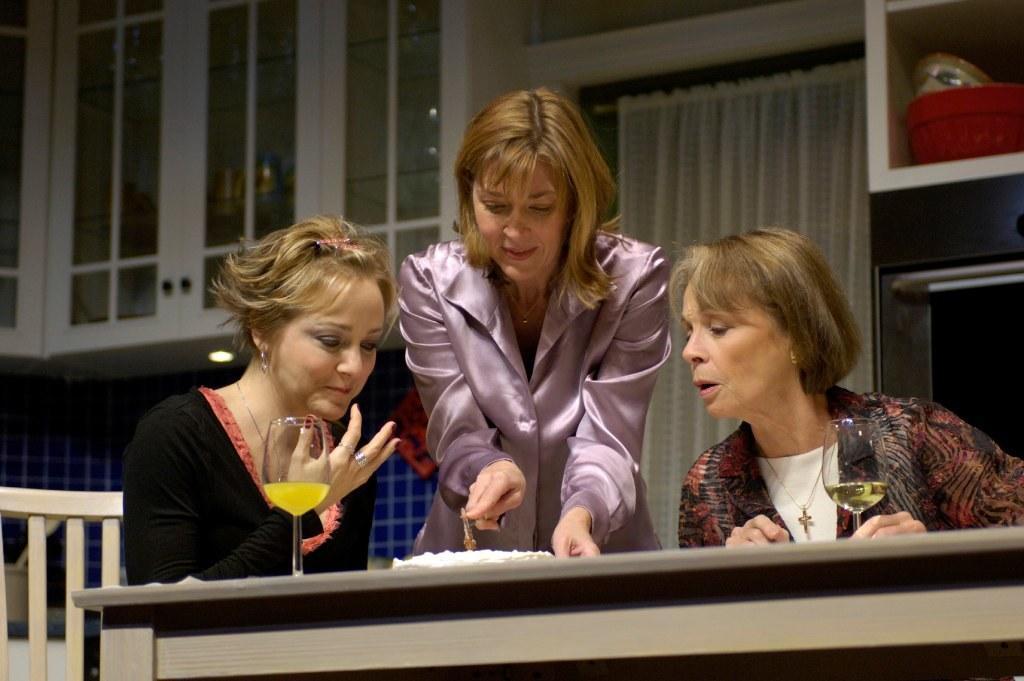Please provide a concise description of this image. On the background we can see cupboard, white curtain and a red basket in a cupboard. here we can see one women at the right side of the picture holding a glass in her hand. At the left side of the picture we can see other women sitting on a chair in front of a table and there is a glass and a cake on the table. This woman is standing in front of a table. 